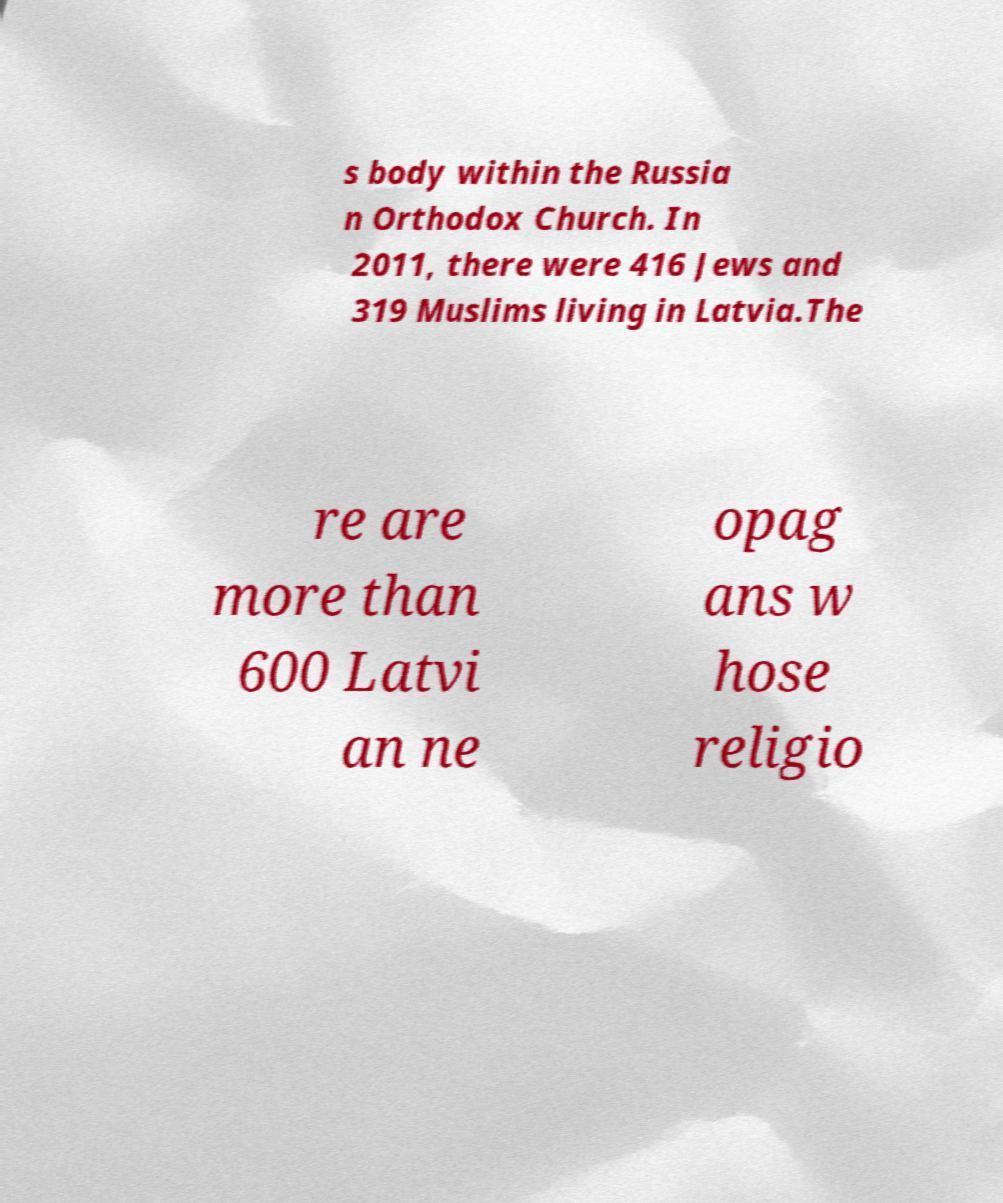There's text embedded in this image that I need extracted. Can you transcribe it verbatim? s body within the Russia n Orthodox Church. In 2011, there were 416 Jews and 319 Muslims living in Latvia.The re are more than 600 Latvi an ne opag ans w hose religio 